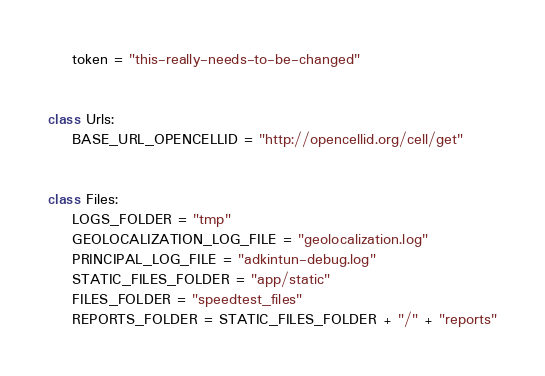Convert code to text. <code><loc_0><loc_0><loc_500><loc_500><_Python_>    token = "this-really-needs-to-be-changed"


class Urls:
    BASE_URL_OPENCELLID = "http://opencellid.org/cell/get"


class Files:
    LOGS_FOLDER = "tmp"
    GEOLOCALIZATION_LOG_FILE = "geolocalization.log"
    PRINCIPAL_LOG_FILE = "adkintun-debug.log"
    STATIC_FILES_FOLDER = "app/static"
    FILES_FOLDER = "speedtest_files"
    REPORTS_FOLDER = STATIC_FILES_FOLDER + "/" + "reports"
</code> 